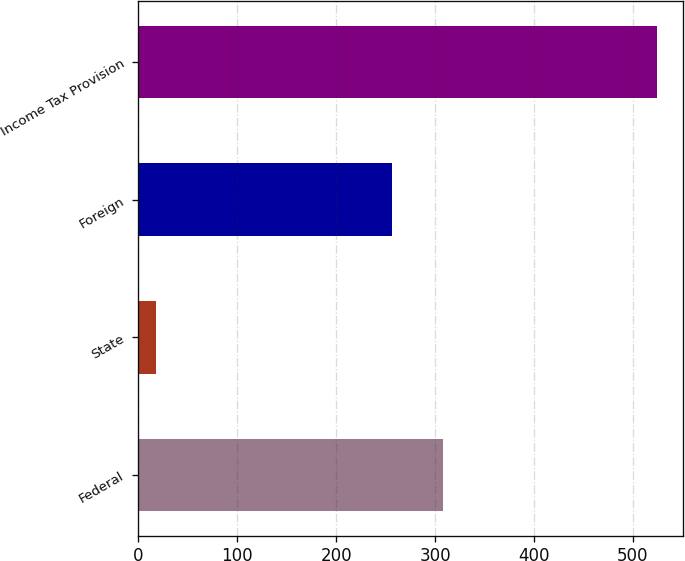Convert chart to OTSL. <chart><loc_0><loc_0><loc_500><loc_500><bar_chart><fcel>Federal<fcel>State<fcel>Foreign<fcel>Income Tax Provision<nl><fcel>307.56<fcel>17.7<fcel>256.9<fcel>524.3<nl></chart> 